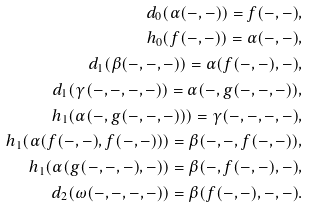Convert formula to latex. <formula><loc_0><loc_0><loc_500><loc_500>d _ { 0 } ( \alpha ( - , - ) ) = f ( - , - ) , \\ h _ { 0 } ( f ( - , - ) ) = \alpha ( - , - ) , \\ d _ { 1 } ( \beta ( - , - , - ) ) = \alpha ( f ( - , - ) , - ) , \\ d _ { 1 } ( \gamma ( - , - , - , - ) ) = \alpha ( - , g ( - , - , - ) ) , \\ h _ { 1 } ( \alpha ( - , g ( - , - , - ) ) ) = \gamma ( - , - , - , - ) , \\ h _ { 1 } ( \alpha ( f ( - , - ) , f ( - , - ) ) ) = \beta ( - , - , f ( - , - ) ) , \\ h _ { 1 } ( \alpha ( g ( - , - , - ) , - ) ) = \beta ( - , f ( - , - ) , - ) , \\ d _ { 2 } ( \omega ( - , - , - , - ) ) = \beta ( f ( - , - ) , - , - ) .</formula> 